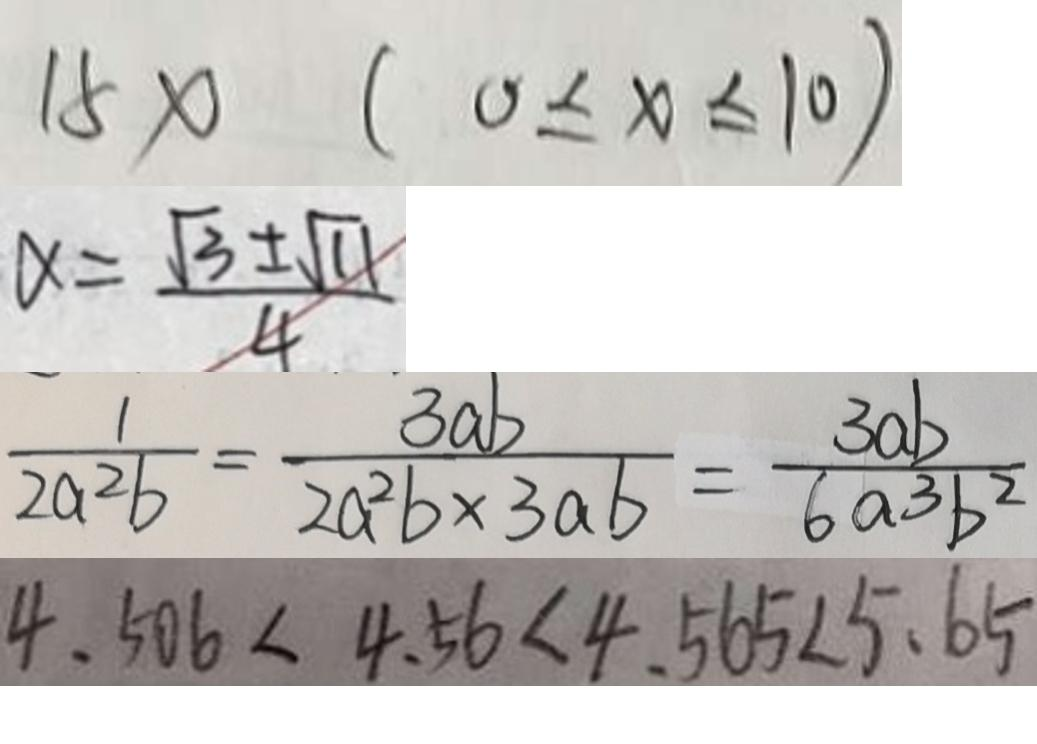Convert formula to latex. <formula><loc_0><loc_0><loc_500><loc_500>1 5 x ( 0 \leq x \leq 1 0 ) 
 \alpha = \frac { \sqrt { 3 } \pm \sqrt { 1 1 } } { 4 } 
 \frac { 1 } { 2 a ^ { 2 } b } = \frac { 3 a b } { 2 a ^ { 2 } b \times 3 a b } = \frac { 3 a b } { 6 a 3 b ^ { 2 } } 
 4 . 5 0 6 < 4 . 5 6 < 4 . 5 6 5 < 5 . 6 5</formula> 